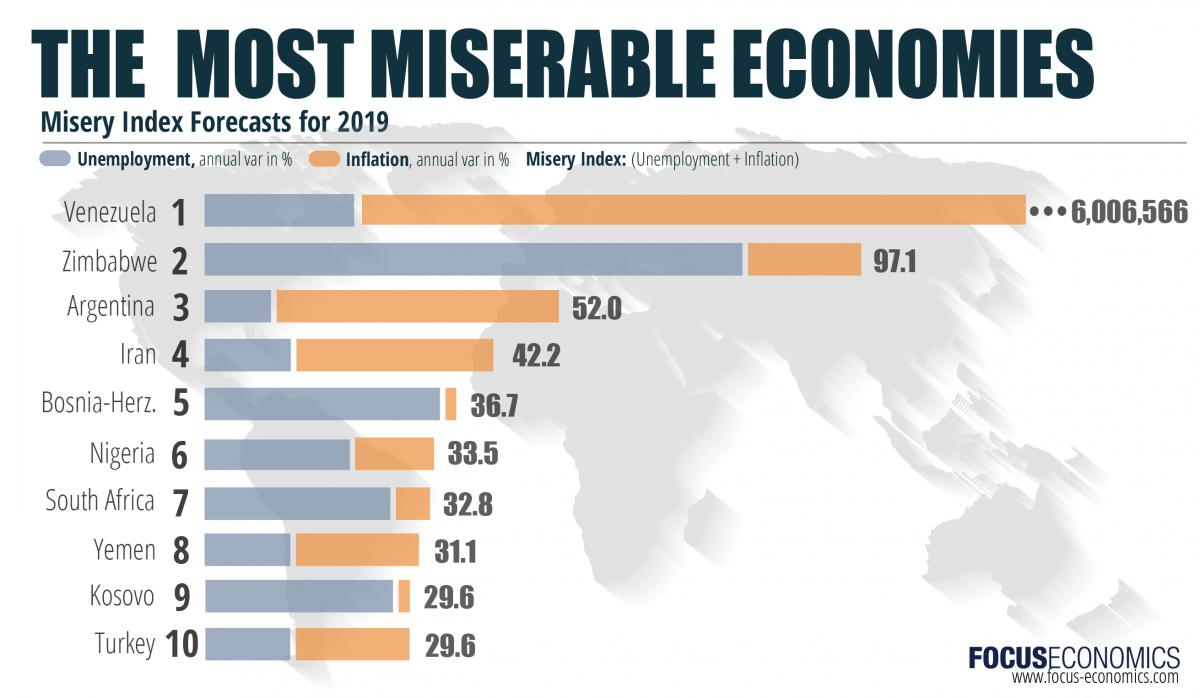Point out several critical features in this image. According to the Misery Index Forecasts for 2019, Argentina has the least annual variance percentage of unemployment among countries. According to the Misery Index Forecasts for 2019, the misery index of Iran is estimated to be 42.2, indicating a high level of economic hardship and political oppression for the country's citizens. According to the Misery Index Forecasts for 2019, Argentina has the second highest annual variance percentage of inflation among countries. According to the Misery Index Forecasts for 2019, Venezuela has the highest annual variance percentage of inflation among countries. According to the Misery Index Forecasts for 2019, Venezuela has the highest misery index, which is a measure of overall national misery. 